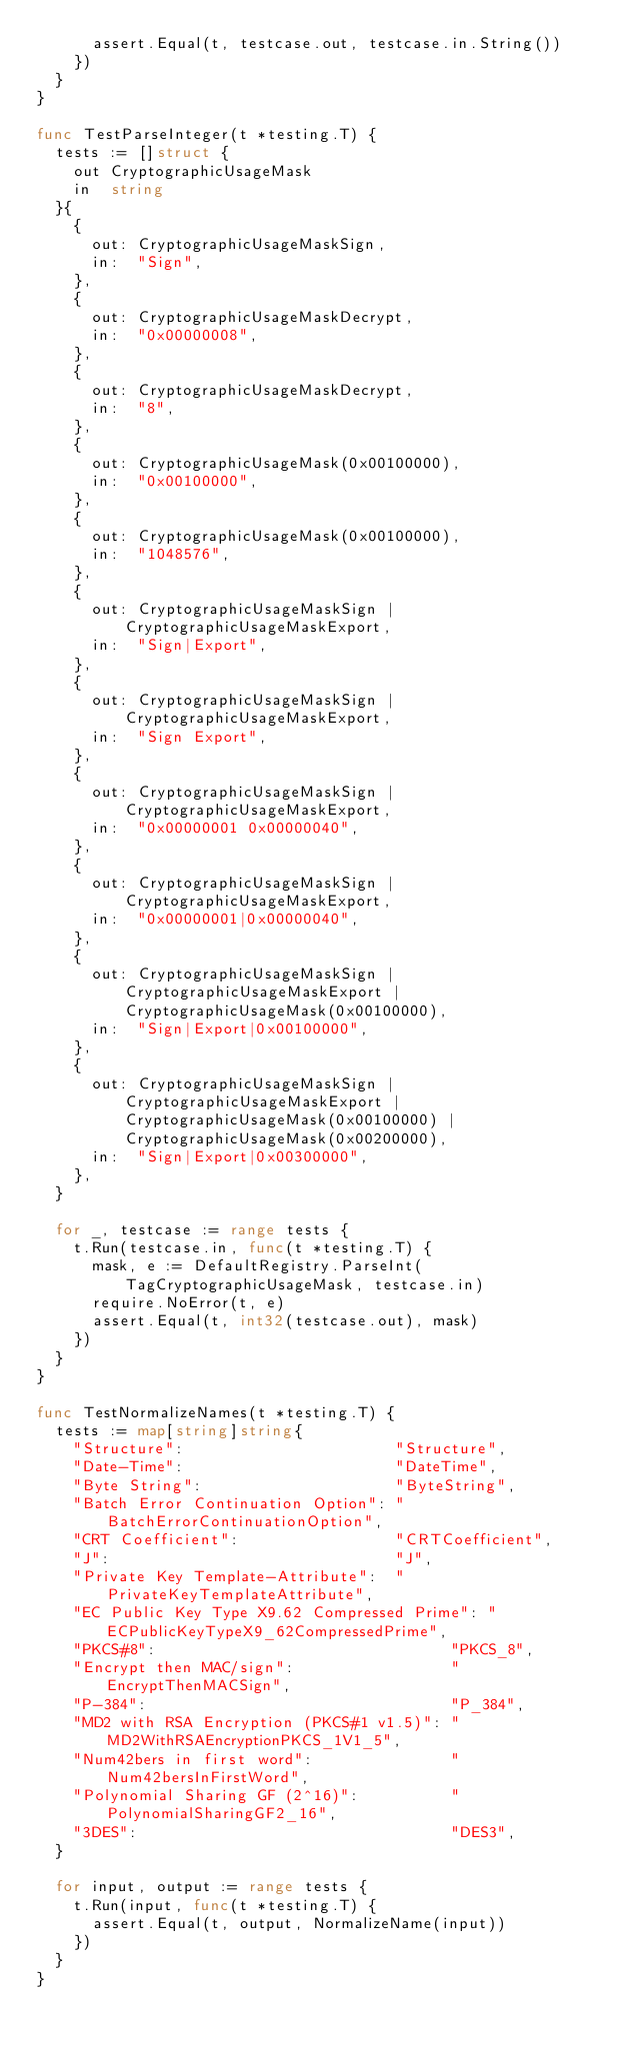<code> <loc_0><loc_0><loc_500><loc_500><_Go_>			assert.Equal(t, testcase.out, testcase.in.String())
		})
	}
}

func TestParseInteger(t *testing.T) {
	tests := []struct {
		out CryptographicUsageMask
		in  string
	}{
		{
			out: CryptographicUsageMaskSign,
			in:  "Sign",
		},
		{
			out: CryptographicUsageMaskDecrypt,
			in:  "0x00000008",
		},
		{
			out: CryptographicUsageMaskDecrypt,
			in:  "8",
		},
		{
			out: CryptographicUsageMask(0x00100000),
			in:  "0x00100000",
		},
		{
			out: CryptographicUsageMask(0x00100000),
			in:  "1048576",
		},
		{
			out: CryptographicUsageMaskSign | CryptographicUsageMaskExport,
			in:  "Sign|Export",
		},
		{
			out: CryptographicUsageMaskSign | CryptographicUsageMaskExport,
			in:  "Sign Export",
		},
		{
			out: CryptographicUsageMaskSign | CryptographicUsageMaskExport,
			in:  "0x00000001 0x00000040",
		},
		{
			out: CryptographicUsageMaskSign | CryptographicUsageMaskExport,
			in:  "0x00000001|0x00000040",
		},
		{
			out: CryptographicUsageMaskSign | CryptographicUsageMaskExport | CryptographicUsageMask(0x00100000),
			in:  "Sign|Export|0x00100000",
		},
		{
			out: CryptographicUsageMaskSign | CryptographicUsageMaskExport | CryptographicUsageMask(0x00100000) | CryptographicUsageMask(0x00200000),
			in:  "Sign|Export|0x00300000",
		},
	}

	for _, testcase := range tests {
		t.Run(testcase.in, func(t *testing.T) {
			mask, e := DefaultRegistry.ParseInt(TagCryptographicUsageMask, testcase.in)
			require.NoError(t, e)
			assert.Equal(t, int32(testcase.out), mask)
		})
	}
}

func TestNormalizeNames(t *testing.T) {
	tests := map[string]string{
		"Structure":                       "Structure",
		"Date-Time":                       "DateTime",
		"Byte String":                     "ByteString",
		"Batch Error Continuation Option": "BatchErrorContinuationOption",
		"CRT Coefficient":                 "CRTCoefficient",
		"J":                               "J",
		"Private Key Template-Attribute":  "PrivateKeyTemplateAttribute",
		"EC Public Key Type X9.62 Compressed Prime": "ECPublicKeyTypeX9_62CompressedPrime",
		"PKCS#8":                                "PKCS_8",
		"Encrypt then MAC/sign":                 "EncryptThenMACSign",
		"P-384":                                 "P_384",
		"MD2 with RSA Encryption (PKCS#1 v1.5)": "MD2WithRSAEncryptionPKCS_1V1_5",
		"Num42bers in first word":               "Num42bersInFirstWord",
		"Polynomial Sharing GF (2^16)":          "PolynomialSharingGF2_16",
		"3DES":                                  "DES3",
	}

	for input, output := range tests {
		t.Run(input, func(t *testing.T) {
			assert.Equal(t, output, NormalizeName(input))
		})
	}
}
</code> 